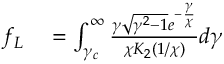Convert formula to latex. <formula><loc_0><loc_0><loc_500><loc_500>\begin{array} { r l } { f _ { L } } & = \int _ { \gamma _ { c } } ^ { \infty } \frac { \gamma \sqrt { \gamma ^ { 2 } - 1 } e ^ { - \frac { \gamma } { \chi } } } { \chi K _ { 2 } \left ( 1 / \chi \right ) } d \gamma } \end{array}</formula> 